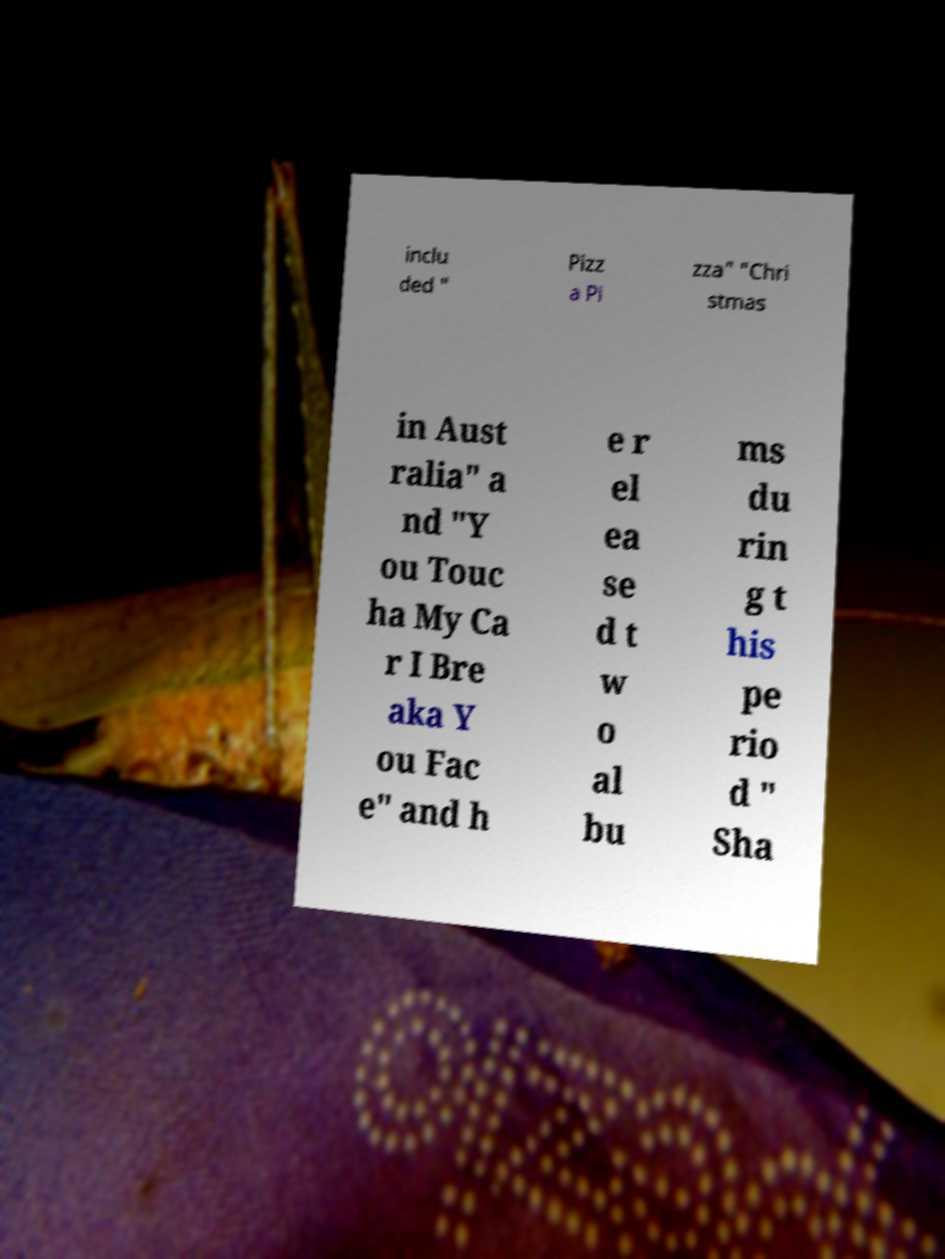Could you extract and type out the text from this image? inclu ded " Pizz a Pi zza" "Chri stmas in Aust ralia" a nd "Y ou Touc ha My Ca r I Bre aka Y ou Fac e" and h e r el ea se d t w o al bu ms du rin g t his pe rio d " Sha 